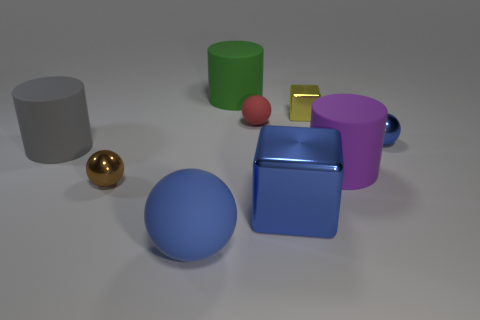Subtract all red rubber balls. How many balls are left? 3 Subtract all red balls. How many balls are left? 3 Subtract all cylinders. How many objects are left? 6 Subtract 1 spheres. How many spheres are left? 3 Subtract all gray blocks. How many cyan balls are left? 0 Subtract all tiny matte balls. Subtract all big gray rubber objects. How many objects are left? 7 Add 6 big gray rubber objects. How many big gray rubber objects are left? 7 Add 6 tiny purple shiny objects. How many tiny purple shiny objects exist? 6 Subtract 1 gray cylinders. How many objects are left? 8 Subtract all purple cylinders. Subtract all gray spheres. How many cylinders are left? 2 